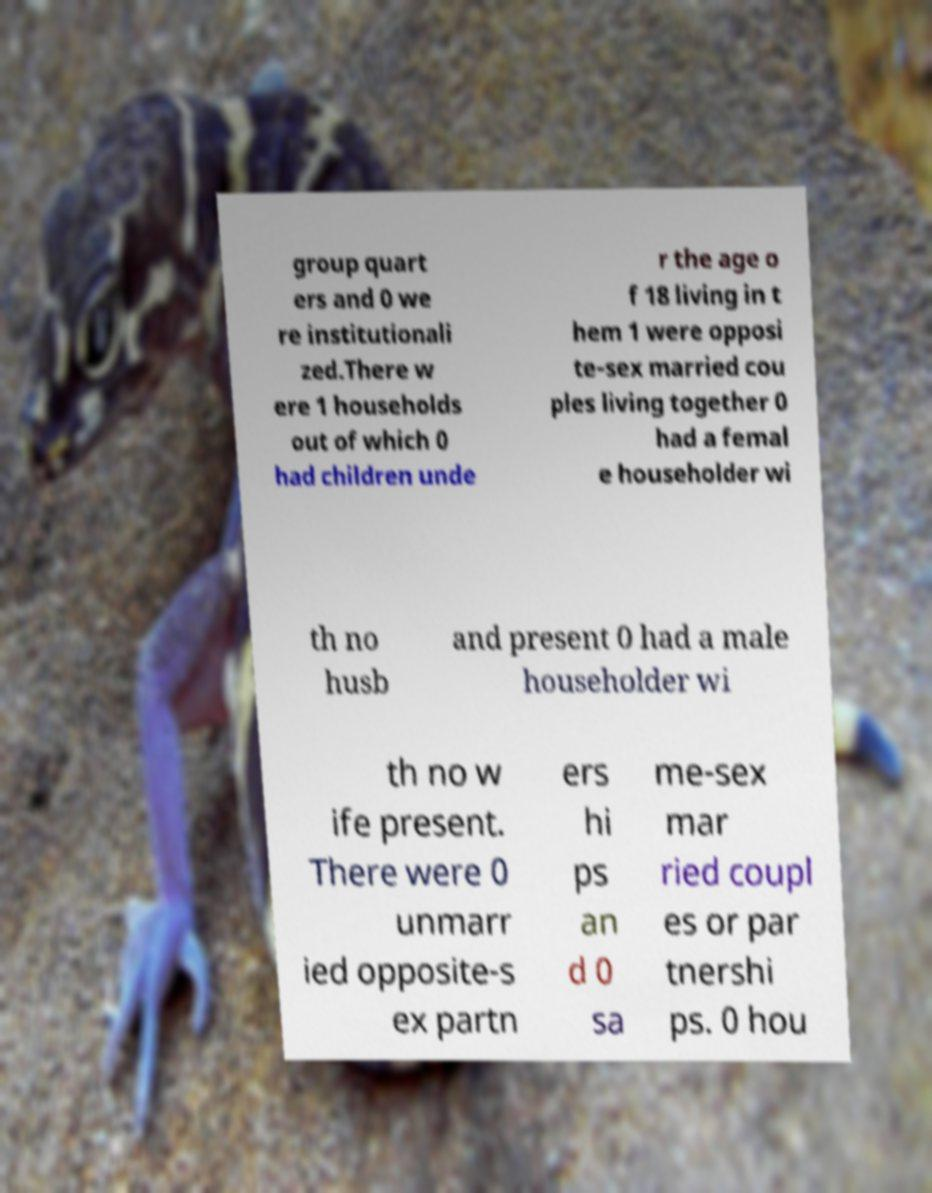Could you assist in decoding the text presented in this image and type it out clearly? group quart ers and 0 we re institutionali zed.There w ere 1 households out of which 0 had children unde r the age o f 18 living in t hem 1 were opposi te-sex married cou ples living together 0 had a femal e householder wi th no husb and present 0 had a male householder wi th no w ife present. There were 0 unmarr ied opposite-s ex partn ers hi ps an d 0 sa me-sex mar ried coupl es or par tnershi ps. 0 hou 